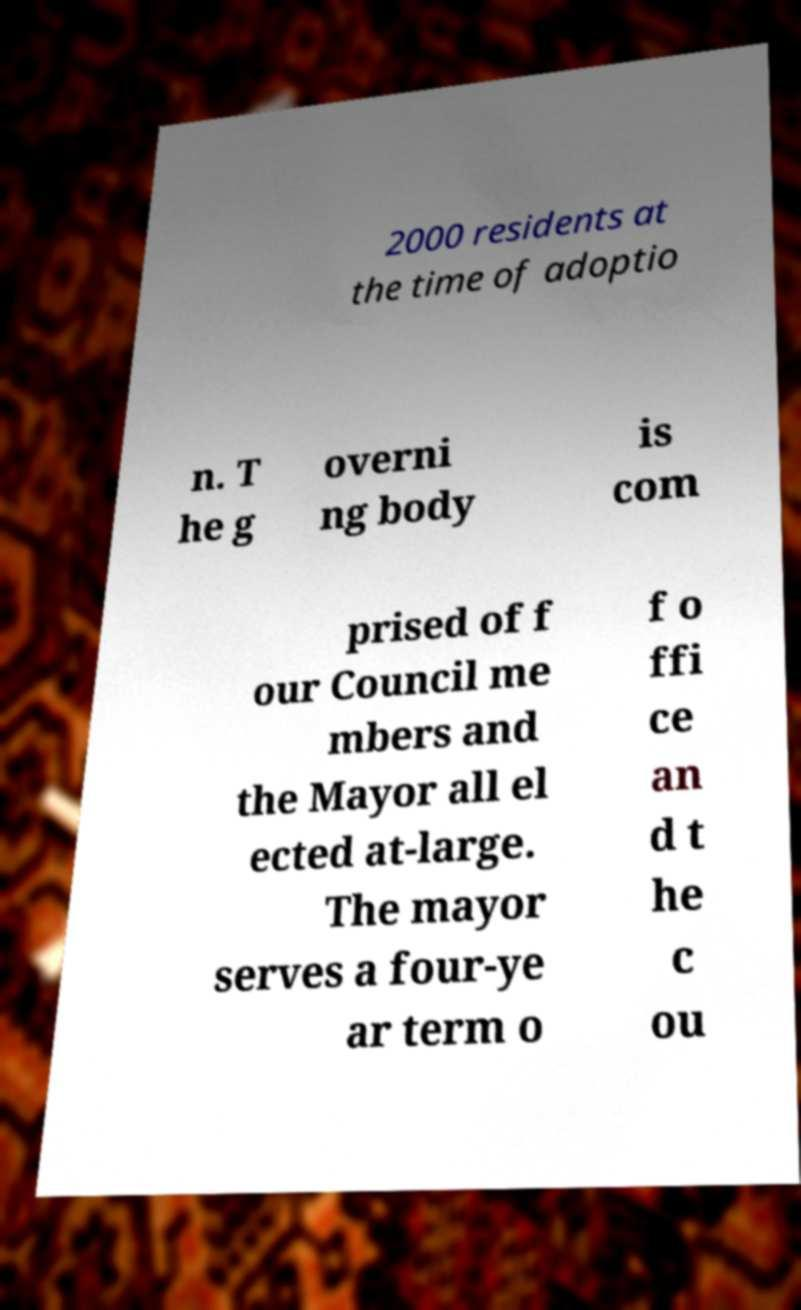Could you extract and type out the text from this image? 2000 residents at the time of adoptio n. T he g overni ng body is com prised of f our Council me mbers and the Mayor all el ected at-large. The mayor serves a four-ye ar term o f o ffi ce an d t he c ou 